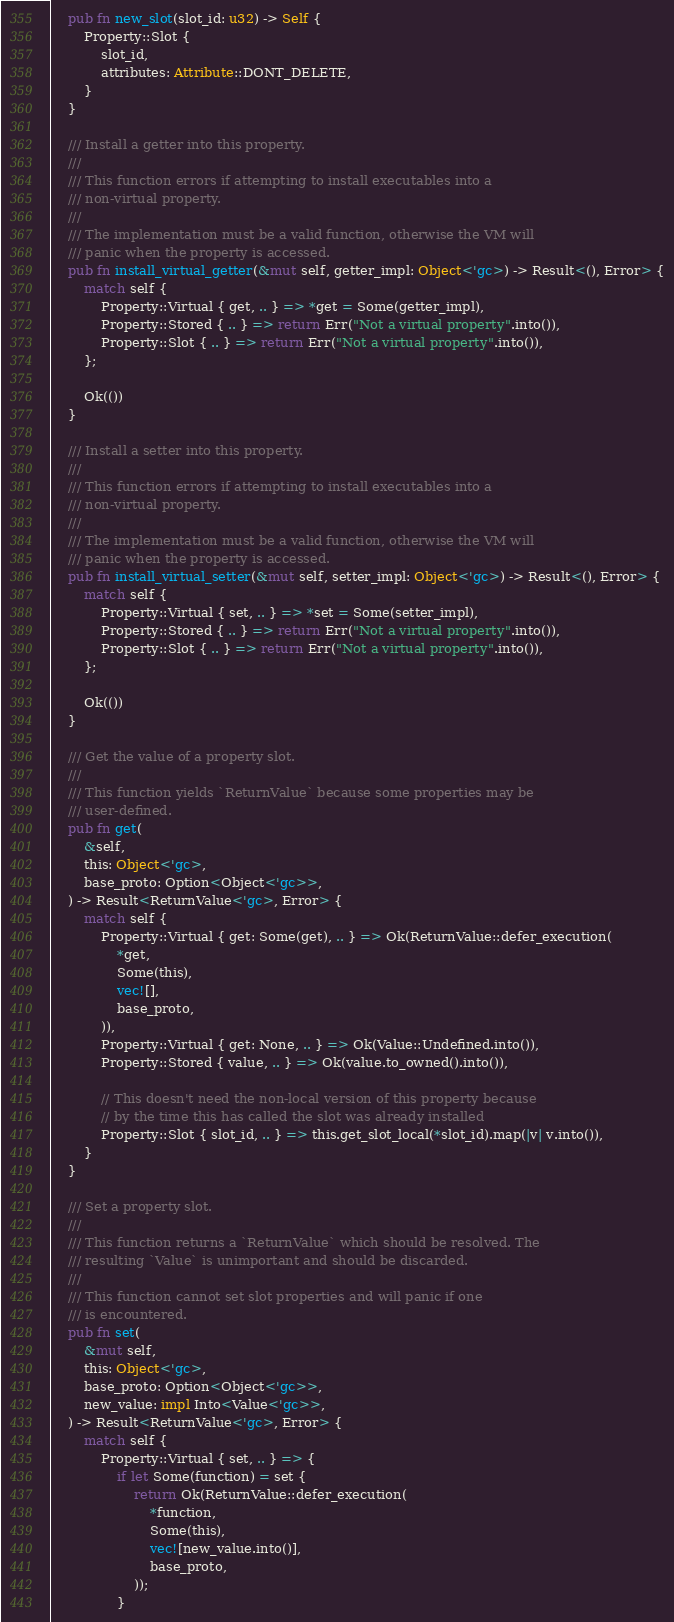<code> <loc_0><loc_0><loc_500><loc_500><_Rust_>    pub fn new_slot(slot_id: u32) -> Self {
        Property::Slot {
            slot_id,
            attributes: Attribute::DONT_DELETE,
        }
    }

    /// Install a getter into this property.
    ///
    /// This function errors if attempting to install executables into a
    /// non-virtual property.
    ///
    /// The implementation must be a valid function, otherwise the VM will
    /// panic when the property is accessed.
    pub fn install_virtual_getter(&mut self, getter_impl: Object<'gc>) -> Result<(), Error> {
        match self {
            Property::Virtual { get, .. } => *get = Some(getter_impl),
            Property::Stored { .. } => return Err("Not a virtual property".into()),
            Property::Slot { .. } => return Err("Not a virtual property".into()),
        };

        Ok(())
    }

    /// Install a setter into this property.
    ///
    /// This function errors if attempting to install executables into a
    /// non-virtual property.
    ///
    /// The implementation must be a valid function, otherwise the VM will
    /// panic when the property is accessed.
    pub fn install_virtual_setter(&mut self, setter_impl: Object<'gc>) -> Result<(), Error> {
        match self {
            Property::Virtual { set, .. } => *set = Some(setter_impl),
            Property::Stored { .. } => return Err("Not a virtual property".into()),
            Property::Slot { .. } => return Err("Not a virtual property".into()),
        };

        Ok(())
    }

    /// Get the value of a property slot.
    ///
    /// This function yields `ReturnValue` because some properties may be
    /// user-defined.
    pub fn get(
        &self,
        this: Object<'gc>,
        base_proto: Option<Object<'gc>>,
    ) -> Result<ReturnValue<'gc>, Error> {
        match self {
            Property::Virtual { get: Some(get), .. } => Ok(ReturnValue::defer_execution(
                *get,
                Some(this),
                vec![],
                base_proto,
            )),
            Property::Virtual { get: None, .. } => Ok(Value::Undefined.into()),
            Property::Stored { value, .. } => Ok(value.to_owned().into()),

            // This doesn't need the non-local version of this property because
            // by the time this has called the slot was already installed
            Property::Slot { slot_id, .. } => this.get_slot_local(*slot_id).map(|v| v.into()),
        }
    }

    /// Set a property slot.
    ///
    /// This function returns a `ReturnValue` which should be resolved. The
    /// resulting `Value` is unimportant and should be discarded.
    ///
    /// This function cannot set slot properties and will panic if one
    /// is encountered.
    pub fn set(
        &mut self,
        this: Object<'gc>,
        base_proto: Option<Object<'gc>>,
        new_value: impl Into<Value<'gc>>,
    ) -> Result<ReturnValue<'gc>, Error> {
        match self {
            Property::Virtual { set, .. } => {
                if let Some(function) = set {
                    return Ok(ReturnValue::defer_execution(
                        *function,
                        Some(this),
                        vec![new_value.into()],
                        base_proto,
                    ));
                }
</code> 